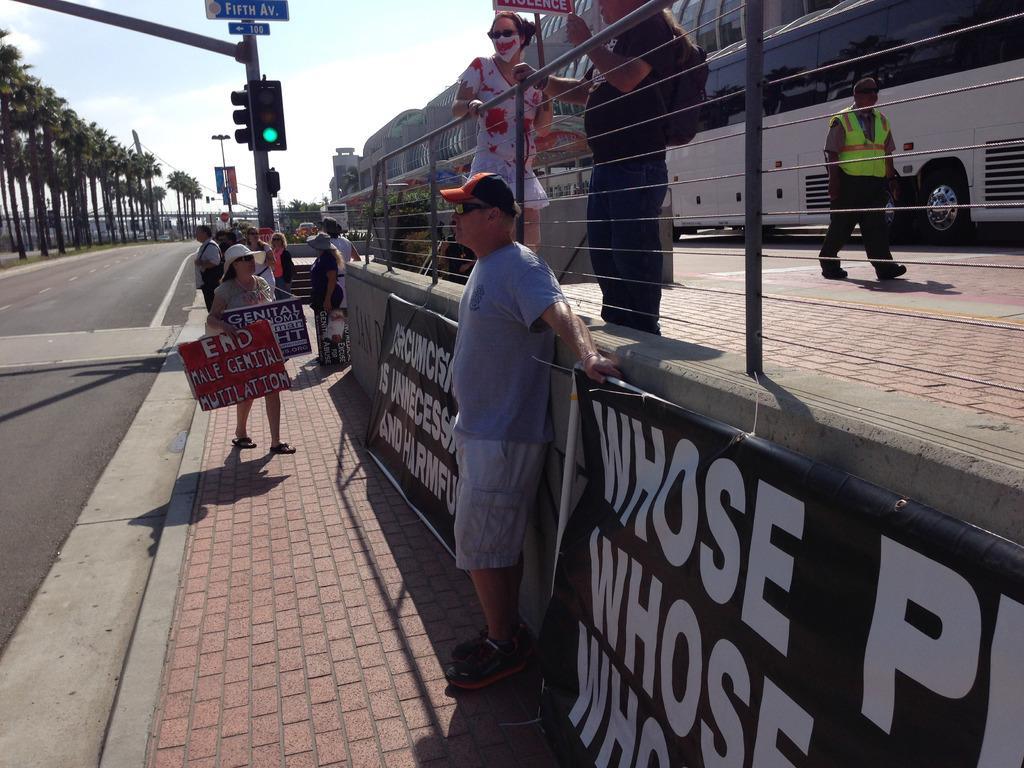In one or two sentences, can you explain what this image depicts? This image is clicked outside. There are trees on the left side. There are so many people in the middle. There is a bus on the right side. There is sky at the top. There is a traffic signal at the top. 